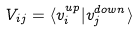<formula> <loc_0><loc_0><loc_500><loc_500>V _ { i j } = \langle v ^ { u p } _ { i } | v ^ { d o w n } _ { j } \rangle</formula> 